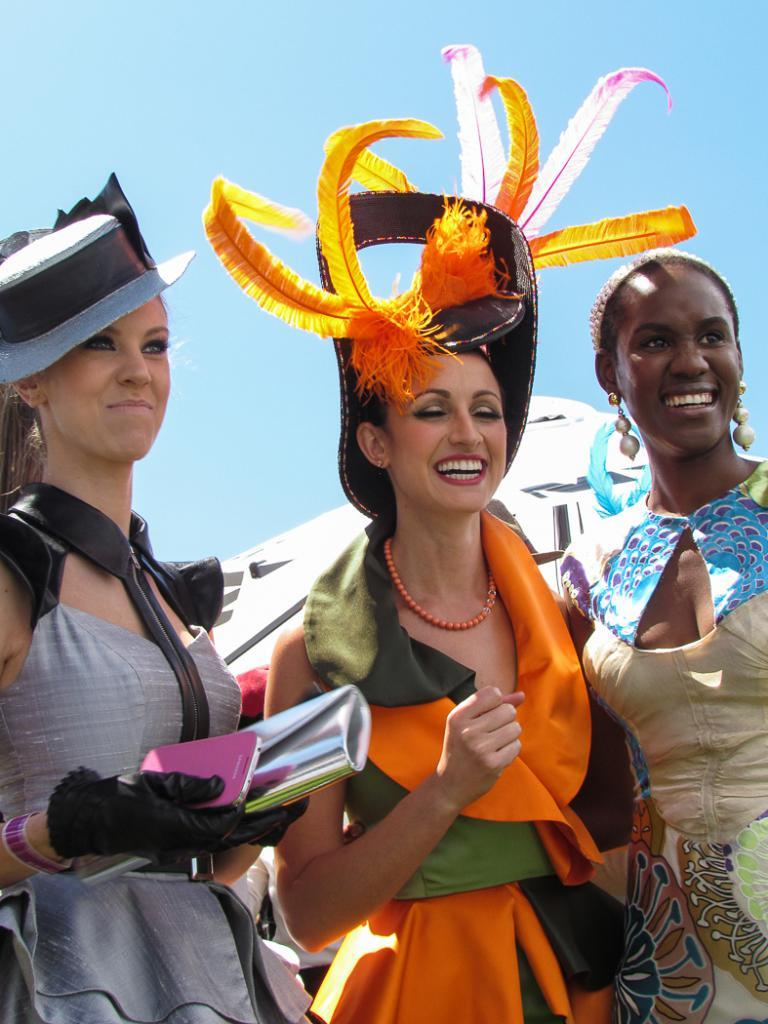How many women are in the image? There are three women in the image. What are the women doing in the image? The women are standing and smiling. What is visible at the top of the image? The sky is visible at the top of the image. What color is the sky in the image? The sky is blue in the image. What type of property is being offered by the minister in the image? There is no minister or property present in the image; it features three women standing and smiling. 